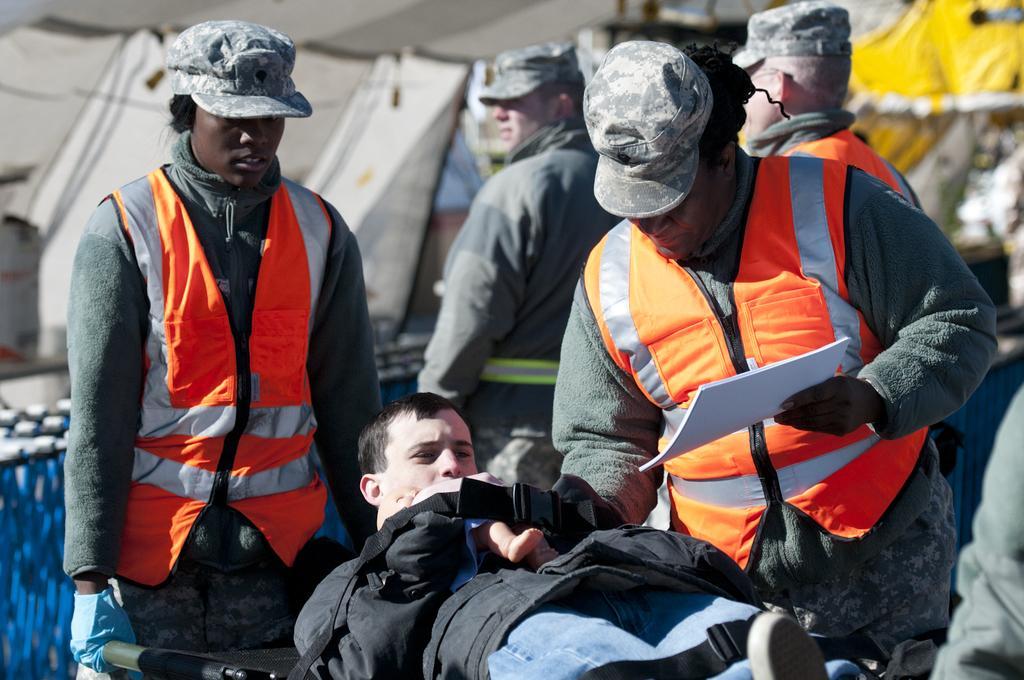Describe this image in one or two sentences. In this image there are two persons carrying a person on the stretcher. Behind them there are another two persons and there are tents. 